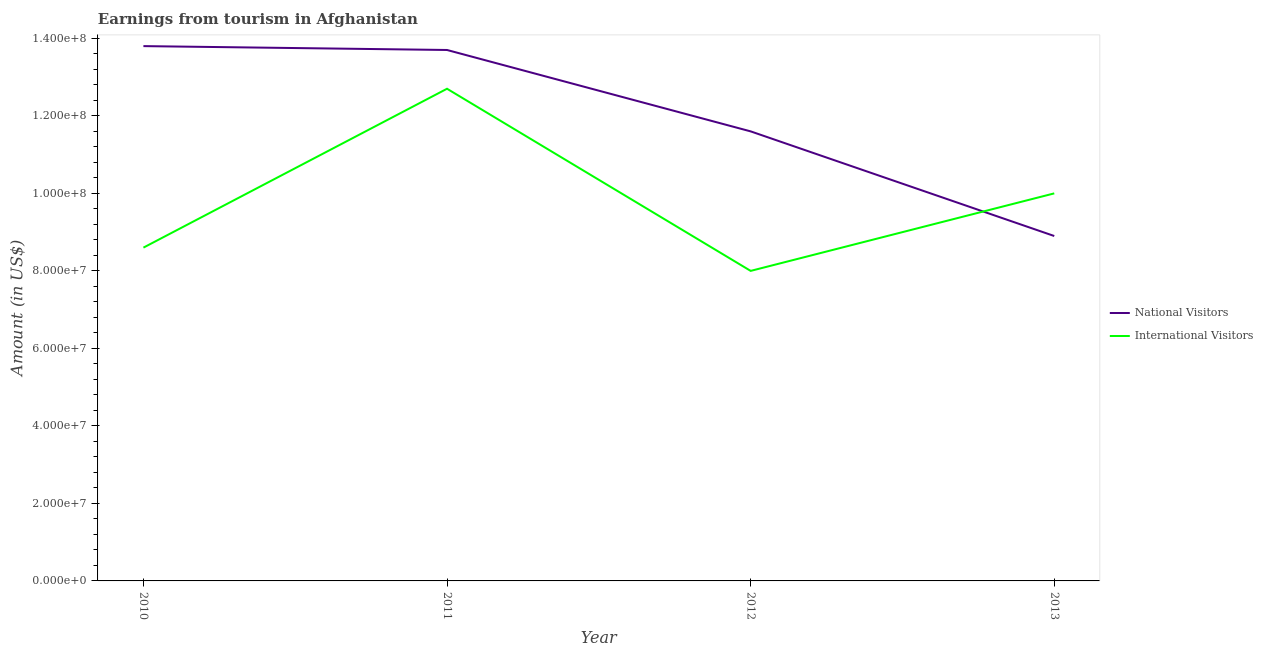Does the line corresponding to amount earned from national visitors intersect with the line corresponding to amount earned from international visitors?
Give a very brief answer. Yes. Is the number of lines equal to the number of legend labels?
Your answer should be compact. Yes. What is the amount earned from national visitors in 2012?
Your response must be concise. 1.16e+08. Across all years, what is the maximum amount earned from international visitors?
Provide a succinct answer. 1.27e+08. Across all years, what is the minimum amount earned from international visitors?
Provide a short and direct response. 8.00e+07. In which year was the amount earned from international visitors maximum?
Make the answer very short. 2011. What is the total amount earned from international visitors in the graph?
Offer a terse response. 3.93e+08. What is the difference between the amount earned from international visitors in 2011 and that in 2013?
Offer a very short reply. 2.70e+07. What is the difference between the amount earned from national visitors in 2010 and the amount earned from international visitors in 2011?
Offer a terse response. 1.10e+07. What is the average amount earned from international visitors per year?
Offer a very short reply. 9.82e+07. In the year 2013, what is the difference between the amount earned from international visitors and amount earned from national visitors?
Keep it short and to the point. 1.10e+07. In how many years, is the amount earned from national visitors greater than 76000000 US$?
Your response must be concise. 4. What is the ratio of the amount earned from national visitors in 2011 to that in 2012?
Ensure brevity in your answer.  1.18. Is the difference between the amount earned from national visitors in 2011 and 2012 greater than the difference between the amount earned from international visitors in 2011 and 2012?
Your answer should be very brief. No. What is the difference between the highest and the second highest amount earned from national visitors?
Ensure brevity in your answer.  1.00e+06. What is the difference between the highest and the lowest amount earned from national visitors?
Offer a very short reply. 4.90e+07. Does the amount earned from national visitors monotonically increase over the years?
Provide a succinct answer. No. Is the amount earned from international visitors strictly greater than the amount earned from national visitors over the years?
Give a very brief answer. No. Is the amount earned from international visitors strictly less than the amount earned from national visitors over the years?
Offer a terse response. No. How many years are there in the graph?
Offer a very short reply. 4. Are the values on the major ticks of Y-axis written in scientific E-notation?
Make the answer very short. Yes. Does the graph contain any zero values?
Your answer should be very brief. No. Where does the legend appear in the graph?
Your answer should be compact. Center right. How are the legend labels stacked?
Your answer should be compact. Vertical. What is the title of the graph?
Your answer should be very brief. Earnings from tourism in Afghanistan. Does "Fixed telephone" appear as one of the legend labels in the graph?
Keep it short and to the point. No. What is the Amount (in US$) of National Visitors in 2010?
Keep it short and to the point. 1.38e+08. What is the Amount (in US$) of International Visitors in 2010?
Your response must be concise. 8.60e+07. What is the Amount (in US$) of National Visitors in 2011?
Give a very brief answer. 1.37e+08. What is the Amount (in US$) in International Visitors in 2011?
Provide a short and direct response. 1.27e+08. What is the Amount (in US$) of National Visitors in 2012?
Make the answer very short. 1.16e+08. What is the Amount (in US$) of International Visitors in 2012?
Offer a very short reply. 8.00e+07. What is the Amount (in US$) of National Visitors in 2013?
Offer a terse response. 8.90e+07. Across all years, what is the maximum Amount (in US$) in National Visitors?
Ensure brevity in your answer.  1.38e+08. Across all years, what is the maximum Amount (in US$) in International Visitors?
Provide a short and direct response. 1.27e+08. Across all years, what is the minimum Amount (in US$) of National Visitors?
Keep it short and to the point. 8.90e+07. Across all years, what is the minimum Amount (in US$) in International Visitors?
Keep it short and to the point. 8.00e+07. What is the total Amount (in US$) in National Visitors in the graph?
Your answer should be compact. 4.80e+08. What is the total Amount (in US$) of International Visitors in the graph?
Your response must be concise. 3.93e+08. What is the difference between the Amount (in US$) in National Visitors in 2010 and that in 2011?
Offer a terse response. 1.00e+06. What is the difference between the Amount (in US$) of International Visitors in 2010 and that in 2011?
Offer a terse response. -4.10e+07. What is the difference between the Amount (in US$) of National Visitors in 2010 and that in 2012?
Keep it short and to the point. 2.20e+07. What is the difference between the Amount (in US$) in International Visitors in 2010 and that in 2012?
Ensure brevity in your answer.  6.00e+06. What is the difference between the Amount (in US$) in National Visitors in 2010 and that in 2013?
Your response must be concise. 4.90e+07. What is the difference between the Amount (in US$) in International Visitors in 2010 and that in 2013?
Give a very brief answer. -1.40e+07. What is the difference between the Amount (in US$) in National Visitors in 2011 and that in 2012?
Offer a terse response. 2.10e+07. What is the difference between the Amount (in US$) of International Visitors in 2011 and that in 2012?
Provide a succinct answer. 4.70e+07. What is the difference between the Amount (in US$) of National Visitors in 2011 and that in 2013?
Your answer should be very brief. 4.80e+07. What is the difference between the Amount (in US$) in International Visitors in 2011 and that in 2013?
Your answer should be compact. 2.70e+07. What is the difference between the Amount (in US$) in National Visitors in 2012 and that in 2013?
Offer a terse response. 2.70e+07. What is the difference between the Amount (in US$) in International Visitors in 2012 and that in 2013?
Offer a terse response. -2.00e+07. What is the difference between the Amount (in US$) of National Visitors in 2010 and the Amount (in US$) of International Visitors in 2011?
Your answer should be very brief. 1.10e+07. What is the difference between the Amount (in US$) of National Visitors in 2010 and the Amount (in US$) of International Visitors in 2012?
Offer a very short reply. 5.80e+07. What is the difference between the Amount (in US$) in National Visitors in 2010 and the Amount (in US$) in International Visitors in 2013?
Make the answer very short. 3.80e+07. What is the difference between the Amount (in US$) of National Visitors in 2011 and the Amount (in US$) of International Visitors in 2012?
Keep it short and to the point. 5.70e+07. What is the difference between the Amount (in US$) in National Visitors in 2011 and the Amount (in US$) in International Visitors in 2013?
Provide a short and direct response. 3.70e+07. What is the difference between the Amount (in US$) of National Visitors in 2012 and the Amount (in US$) of International Visitors in 2013?
Offer a terse response. 1.60e+07. What is the average Amount (in US$) in National Visitors per year?
Make the answer very short. 1.20e+08. What is the average Amount (in US$) of International Visitors per year?
Offer a very short reply. 9.82e+07. In the year 2010, what is the difference between the Amount (in US$) of National Visitors and Amount (in US$) of International Visitors?
Make the answer very short. 5.20e+07. In the year 2011, what is the difference between the Amount (in US$) in National Visitors and Amount (in US$) in International Visitors?
Provide a short and direct response. 1.00e+07. In the year 2012, what is the difference between the Amount (in US$) in National Visitors and Amount (in US$) in International Visitors?
Give a very brief answer. 3.60e+07. In the year 2013, what is the difference between the Amount (in US$) of National Visitors and Amount (in US$) of International Visitors?
Make the answer very short. -1.10e+07. What is the ratio of the Amount (in US$) of National Visitors in 2010 to that in 2011?
Make the answer very short. 1.01. What is the ratio of the Amount (in US$) in International Visitors in 2010 to that in 2011?
Your response must be concise. 0.68. What is the ratio of the Amount (in US$) in National Visitors in 2010 to that in 2012?
Provide a succinct answer. 1.19. What is the ratio of the Amount (in US$) of International Visitors in 2010 to that in 2012?
Give a very brief answer. 1.07. What is the ratio of the Amount (in US$) in National Visitors in 2010 to that in 2013?
Your answer should be very brief. 1.55. What is the ratio of the Amount (in US$) of International Visitors in 2010 to that in 2013?
Your answer should be compact. 0.86. What is the ratio of the Amount (in US$) in National Visitors in 2011 to that in 2012?
Keep it short and to the point. 1.18. What is the ratio of the Amount (in US$) in International Visitors in 2011 to that in 2012?
Offer a very short reply. 1.59. What is the ratio of the Amount (in US$) of National Visitors in 2011 to that in 2013?
Your answer should be very brief. 1.54. What is the ratio of the Amount (in US$) of International Visitors in 2011 to that in 2013?
Your answer should be very brief. 1.27. What is the ratio of the Amount (in US$) in National Visitors in 2012 to that in 2013?
Your response must be concise. 1.3. What is the ratio of the Amount (in US$) in International Visitors in 2012 to that in 2013?
Provide a succinct answer. 0.8. What is the difference between the highest and the second highest Amount (in US$) of International Visitors?
Offer a very short reply. 2.70e+07. What is the difference between the highest and the lowest Amount (in US$) of National Visitors?
Offer a very short reply. 4.90e+07. What is the difference between the highest and the lowest Amount (in US$) of International Visitors?
Your answer should be compact. 4.70e+07. 